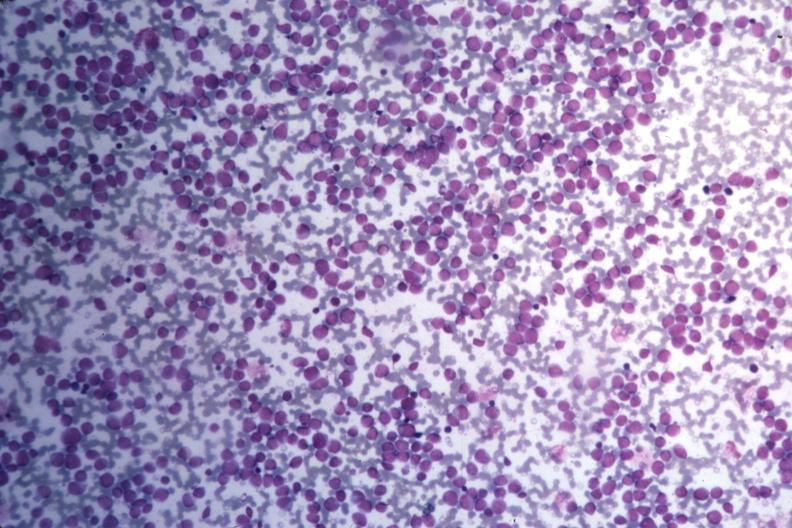what do med wrights stain?
Answer the question using a single word or phrase. Many pleomorphic blast cells readily seen 